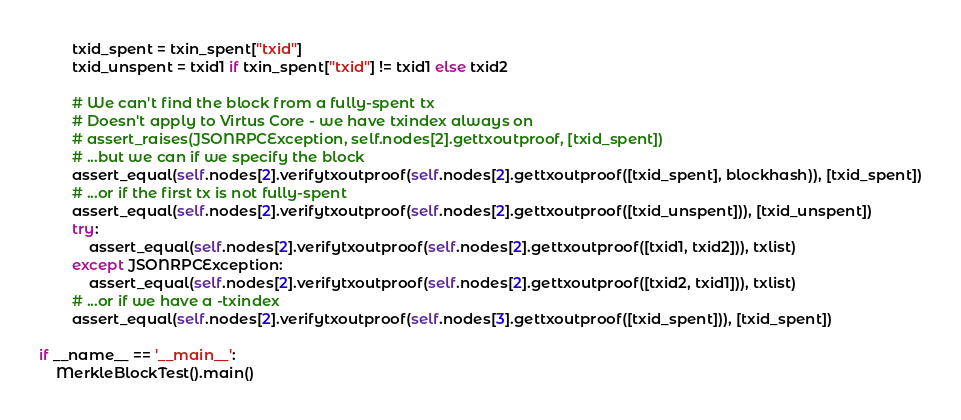Convert code to text. <code><loc_0><loc_0><loc_500><loc_500><_Python_>        txid_spent = txin_spent["txid"]
        txid_unspent = txid1 if txin_spent["txid"] != txid1 else txid2

        # We can't find the block from a fully-spent tx
        # Doesn't apply to Virtus Core - we have txindex always on
        # assert_raises(JSONRPCException, self.nodes[2].gettxoutproof, [txid_spent])
        # ...but we can if we specify the block
        assert_equal(self.nodes[2].verifytxoutproof(self.nodes[2].gettxoutproof([txid_spent], blockhash)), [txid_spent])
        # ...or if the first tx is not fully-spent
        assert_equal(self.nodes[2].verifytxoutproof(self.nodes[2].gettxoutproof([txid_unspent])), [txid_unspent])
        try:
            assert_equal(self.nodes[2].verifytxoutproof(self.nodes[2].gettxoutproof([txid1, txid2])), txlist)
        except JSONRPCException:
            assert_equal(self.nodes[2].verifytxoutproof(self.nodes[2].gettxoutproof([txid2, txid1])), txlist)
        # ...or if we have a -txindex
        assert_equal(self.nodes[2].verifytxoutproof(self.nodes[3].gettxoutproof([txid_spent])), [txid_spent])

if __name__ == '__main__':
    MerkleBlockTest().main()
</code> 